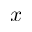<formula> <loc_0><loc_0><loc_500><loc_500>x</formula> 